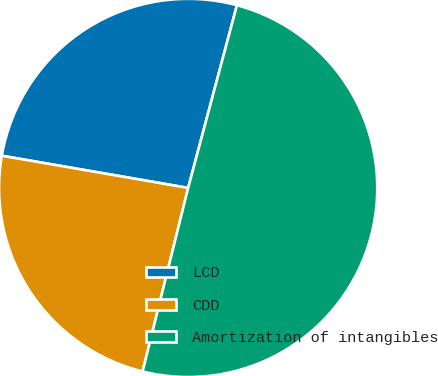<chart> <loc_0><loc_0><loc_500><loc_500><pie_chart><fcel>LCD<fcel>CDD<fcel>Amortization of intangibles<nl><fcel>26.43%<fcel>23.85%<fcel>49.72%<nl></chart> 